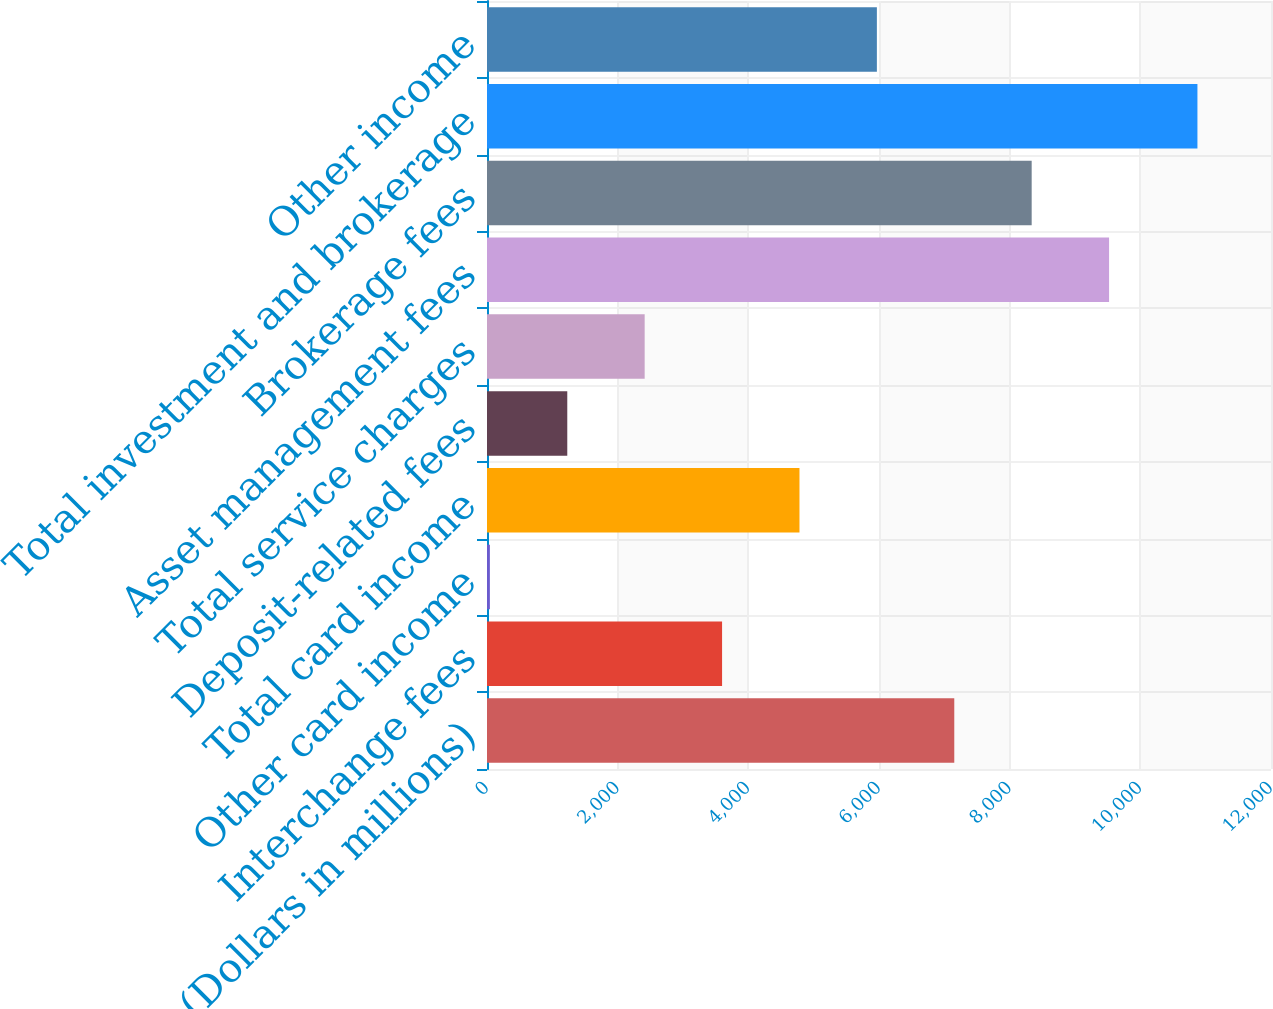Convert chart to OTSL. <chart><loc_0><loc_0><loc_500><loc_500><bar_chart><fcel>(Dollars in millions)<fcel>Interchange fees<fcel>Other card income<fcel>Total card income<fcel>Deposit-related fees<fcel>Total service charges<fcel>Asset management fees<fcel>Brokerage fees<fcel>Total investment and brokerage<fcel>Other income<nl><fcel>7152.2<fcel>3598.1<fcel>44<fcel>4782.8<fcel>1228.7<fcel>2413.4<fcel>9521.6<fcel>8336.9<fcel>10874<fcel>5967.5<nl></chart> 